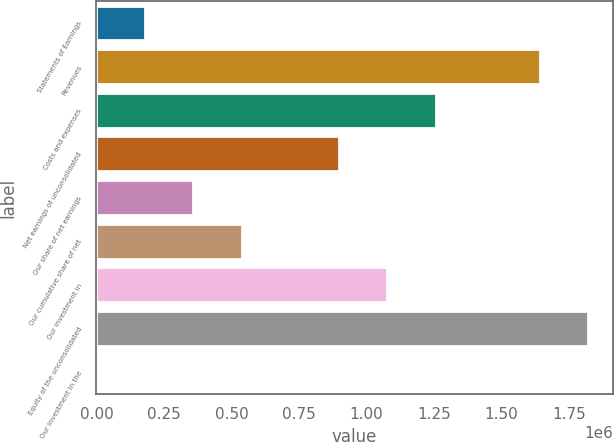Convert chart. <chart><loc_0><loc_0><loc_500><loc_500><bar_chart><fcel>Statements of Earnings<fcel>Revenues<fcel>Costs and expenses<fcel>Net earnings of unconsolidated<fcel>Our share of net earnings<fcel>Our cumulative share of net<fcel>Our investment in<fcel>Equity of the unconsolidated<fcel>Our investment in the<nl><fcel>179544<fcel>1.64102e+06<fcel>1.25652e+06<fcel>897529<fcel>359040<fcel>538536<fcel>1.07703e+06<fcel>1.82051e+06<fcel>47.7<nl></chart> 